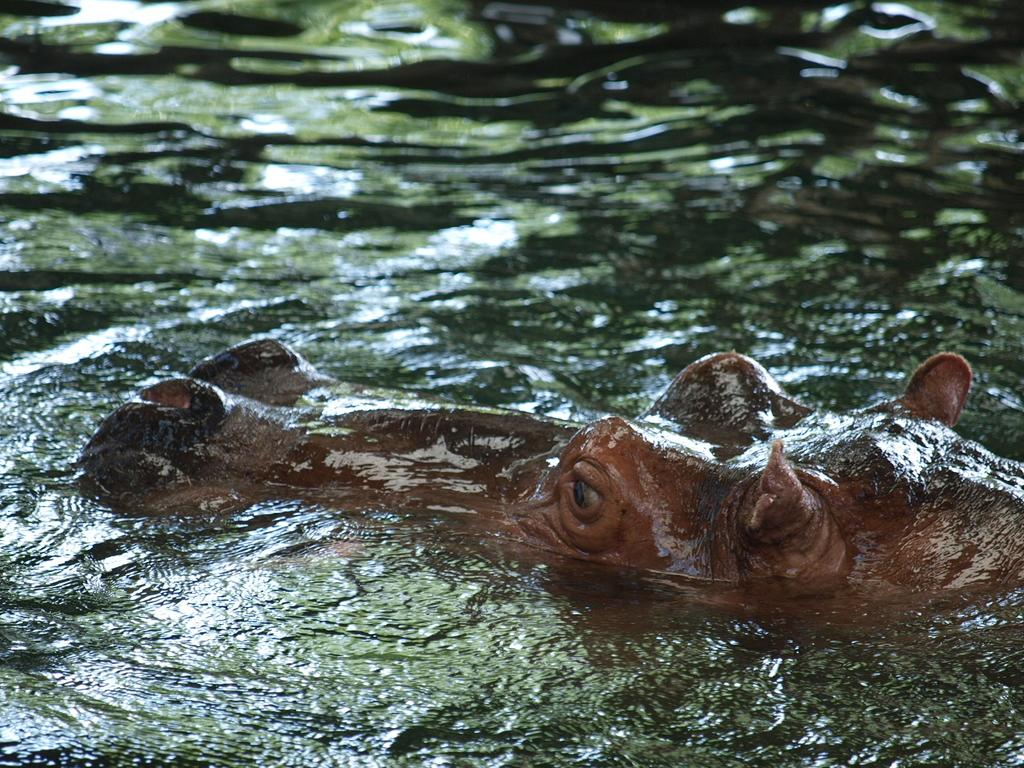What is the main subject of the image? There is an animal in the water. Can you describe the background of the image? The background of the image is blurred. What type of station can be seen in the background of the image? There is no station present in the image; it features an animal in the water with a blurred background. How far away is the string from the animal in the image? There is no string present in the image, so it cannot be determined how far away it might be from the animal. 